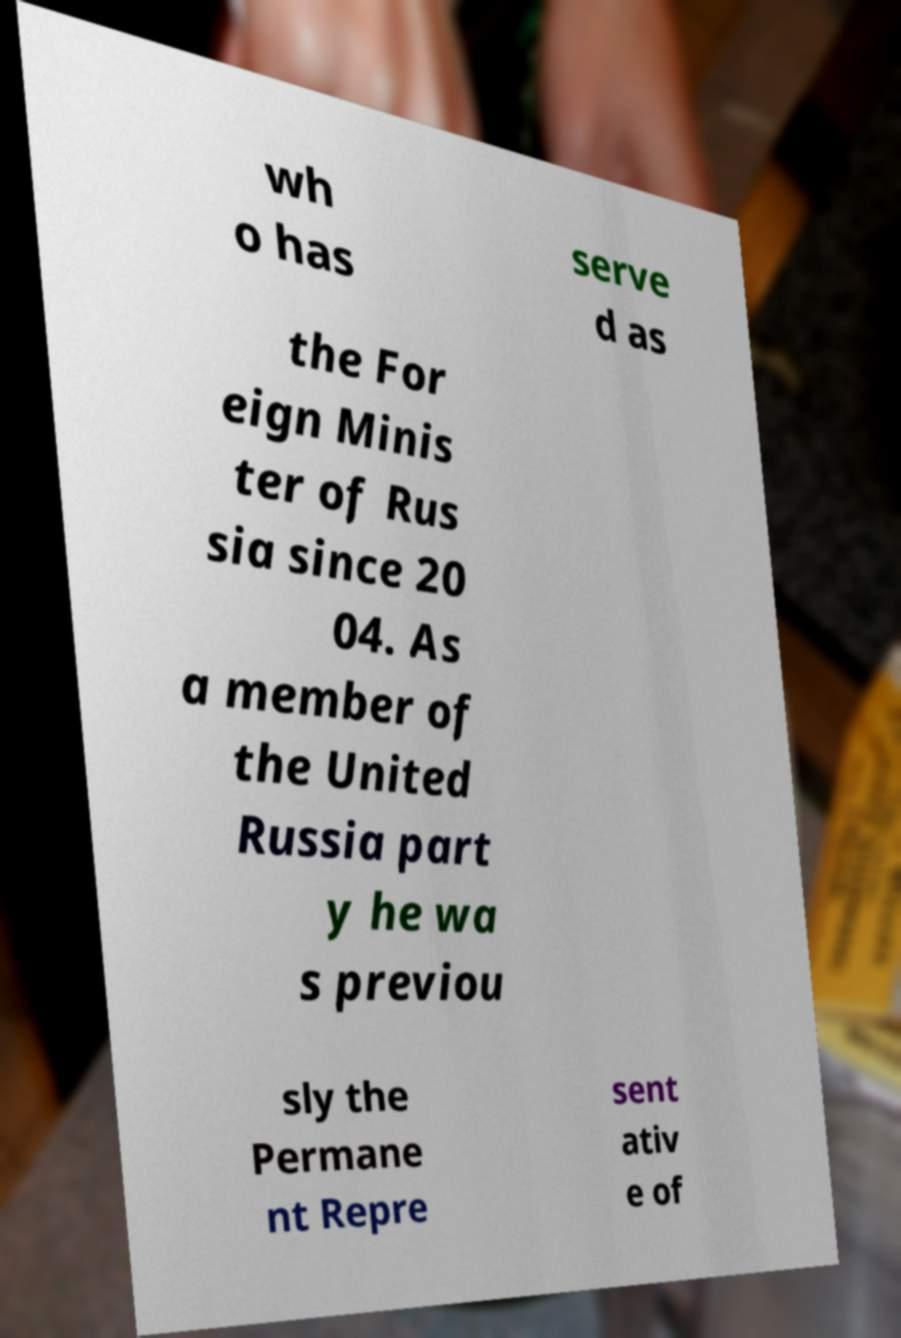Can you read and provide the text displayed in the image?This photo seems to have some interesting text. Can you extract and type it out for me? wh o has serve d as the For eign Minis ter of Rus sia since 20 04. As a member of the United Russia part y he wa s previou sly the Permane nt Repre sent ativ e of 